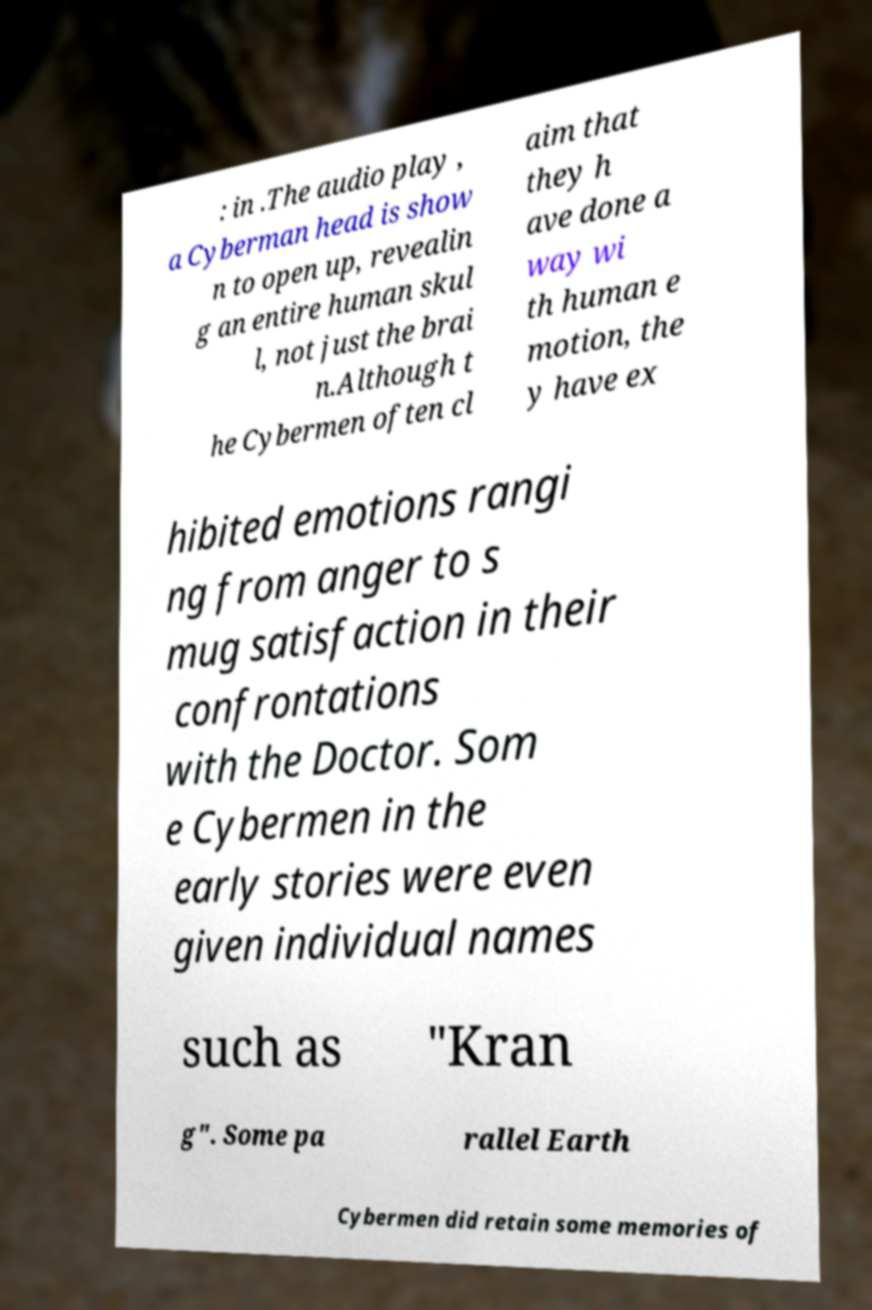Please read and relay the text visible in this image. What does it say? : in .The audio play , a Cyberman head is show n to open up, revealin g an entire human skul l, not just the brai n.Although t he Cybermen often cl aim that they h ave done a way wi th human e motion, the y have ex hibited emotions rangi ng from anger to s mug satisfaction in their confrontations with the Doctor. Som e Cybermen in the early stories were even given individual names such as "Kran g". Some pa rallel Earth Cybermen did retain some memories of 